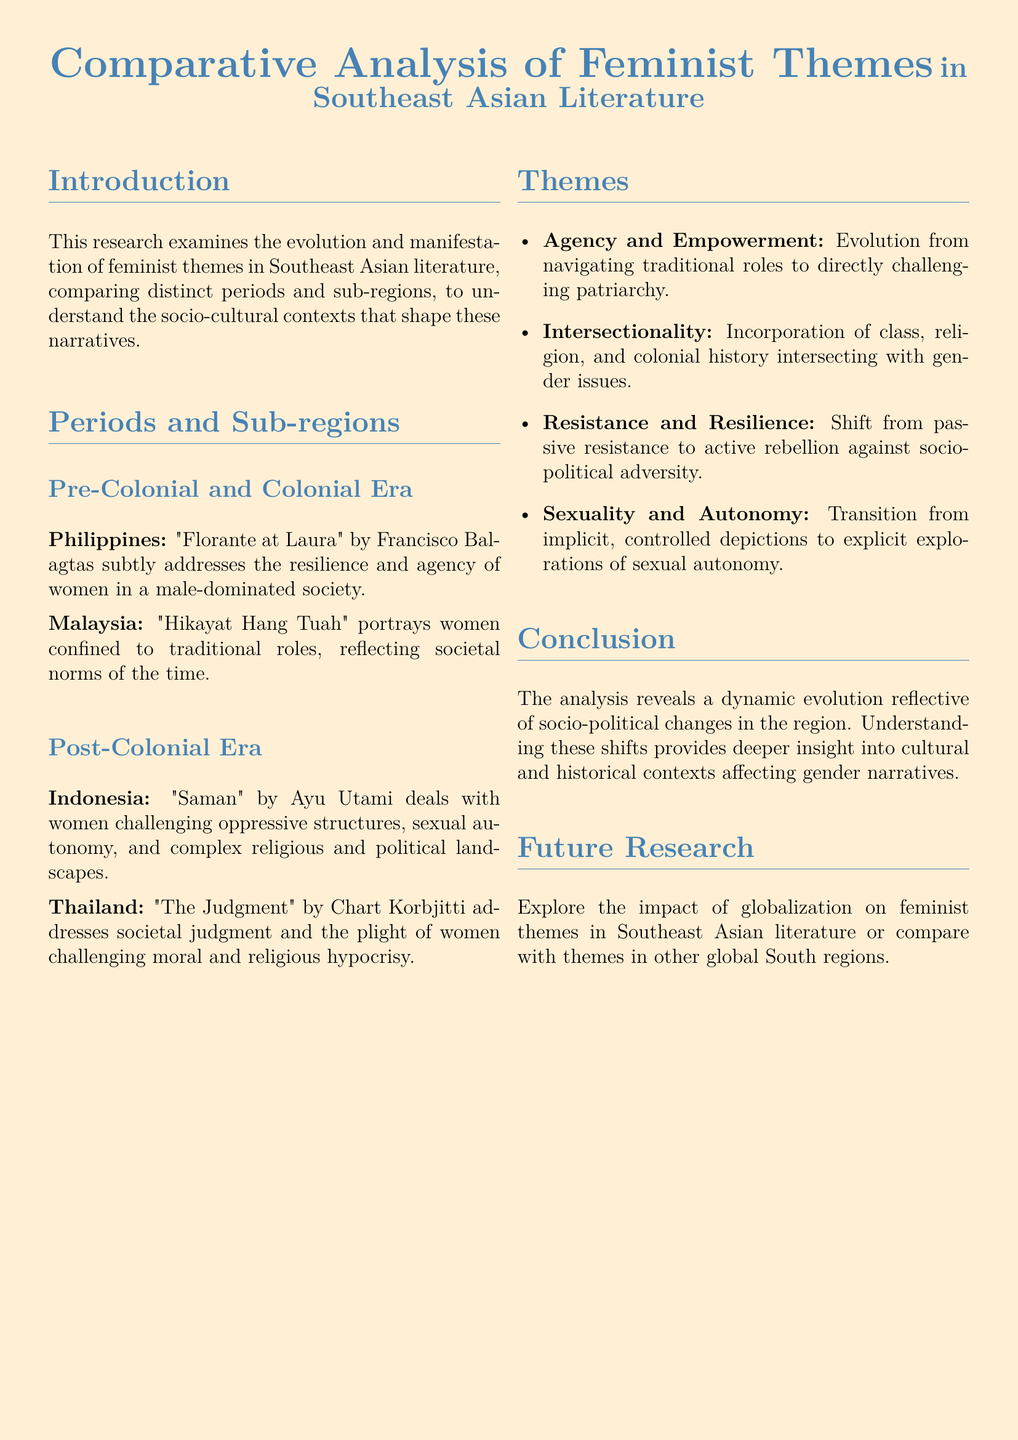What is the title of the document? The title is explicitly stated at the top of the document and is "Comparative Analysis of Feminist Themes in Southeast Asian Literature."
Answer: Comparative Analysis of Feminist Themes in Southeast Asian Literature Who is the author of "Florante at Laura"? The author is mentioned in the discussion of the Pre-Colonial and Colonial Era section, and it states that the author is Francisco Balagtas.
Answer: Francisco Balagtas What sub-region does "Saman" belong to? "Saman" is identified in the Post-Colonial Era section, and it belongs to Indonesia.
Answer: Indonesia What theme reflects a shift from passive resistance to active rebellion? The document lists various themes, and "Resistance and Resilience" specifically indicates this departure from passive to active resistance.
Answer: Resistance and Resilience What period does "Hikayat Hang Tuah" belong to? The document categorizes "Hikayat Hang Tuah" under the Pre-Colonial and Colonial Era.
Answer: Pre-Colonial and Colonial Era What is one proposed area for future research? Future research suggestions are given at the end of the document, and one area proposed is the impact of globalization on feminist themes.
Answer: Impact of globalization on feminist themes What is the main focus of this research? The introduction clearly states the main focus of the research, which is examining the evolution and manifestation of feminist themes in Southeast Asian literature.
Answer: Examining the evolution and manifestation of feminist themes in Southeast Asian literature Which theme encompasses the incorporation of class, religion, and colonial history? The document specifically states that this is represented by the theme "Intersectionality."
Answer: Intersectionality 